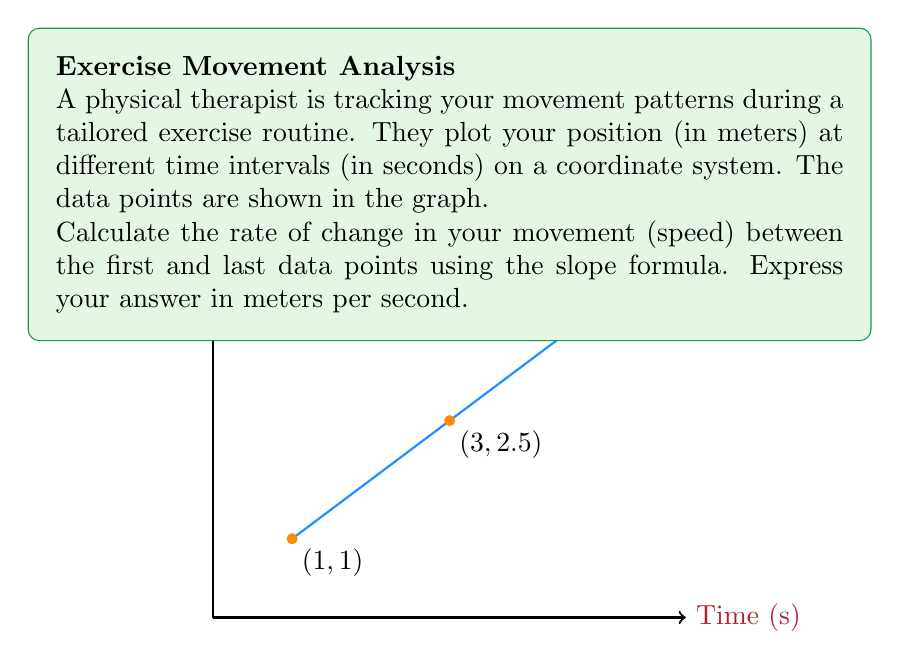Give your solution to this math problem. To calculate the rate of change (speed) using the slope formula, we need to use the following steps:

1) The slope formula is:

   $$m = \frac{y_2 - y_1}{x_2 - x_1}$$

   where $(x_1, y_1)$ is the first point and $(x_2, y_2)$ is the second point.

2) From the given data, we have:
   First point: $(1, 1)$
   Last point: $(5, 4)$

3) Let's substitute these into the formula:

   $$m = \frac{4 - 1}{5 - 1} = \frac{3}{4}$$

4) Simplify:

   $$m = 0.75$$

5) Interpret the result:
   The slope represents the rate of change in distance over time, which is speed.
   The units are meters (distance) per second (time).

Therefore, the speed is 0.75 meters per second.
Answer: $0.75$ m/s 